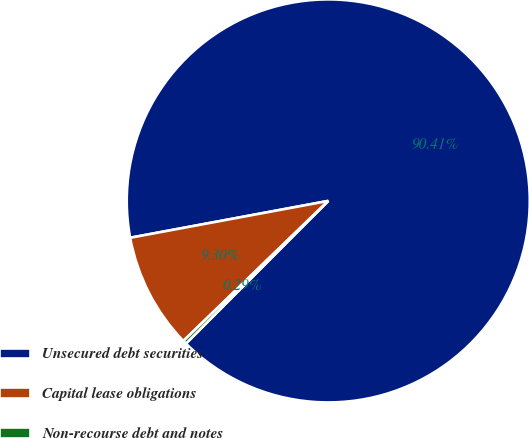<chart> <loc_0><loc_0><loc_500><loc_500><pie_chart><fcel>Unsecured debt securities<fcel>Capital lease obligations<fcel>Non-recourse debt and notes<nl><fcel>90.41%<fcel>9.3%<fcel>0.29%<nl></chart> 